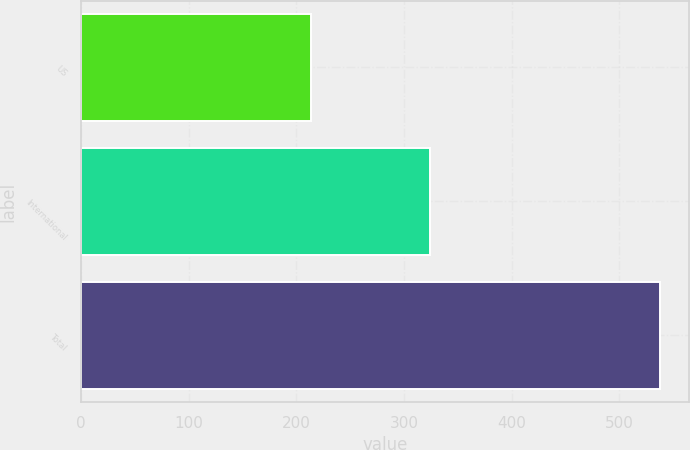Convert chart to OTSL. <chart><loc_0><loc_0><loc_500><loc_500><bar_chart><fcel>US<fcel>International<fcel>Total<nl><fcel>214<fcel>324<fcel>538<nl></chart> 